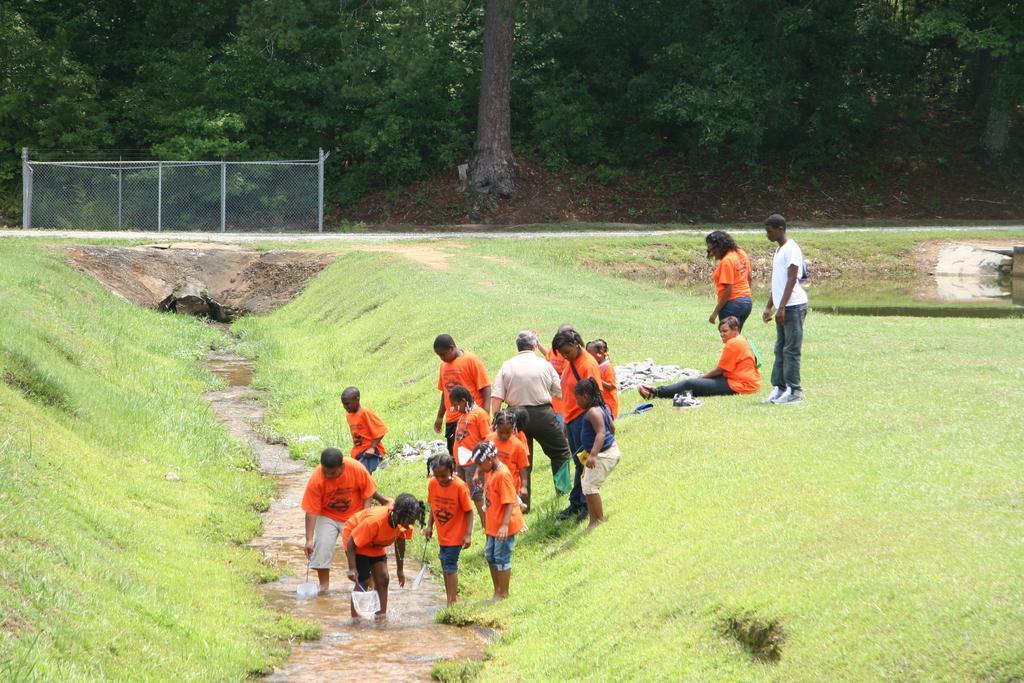Please provide a concise description of this image. This picture describes about group of people, few are standing and a person is seated on the grass, we can see water, in the background we can find few trees, metal rods and a net. 